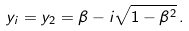Convert formula to latex. <formula><loc_0><loc_0><loc_500><loc_500>y _ { i } = y _ { 2 } = \beta - i \sqrt { 1 - \beta ^ { 2 } } \, .</formula> 